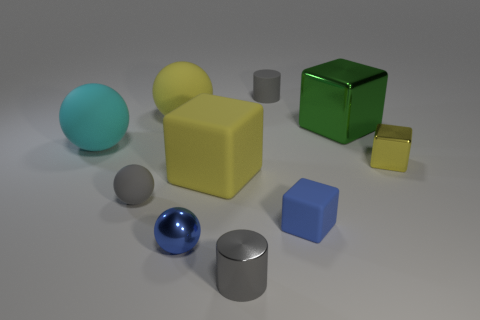Are the blue block and the small gray thing that is in front of the blue metal object made of the same material?
Offer a very short reply. No. There is a shiny thing that is on the right side of the tiny blue metal object and on the left side of the green metallic block; what is its color?
Make the answer very short. Gray. What number of spheres are large yellow matte things or small gray rubber objects?
Provide a short and direct response. 2. Do the big cyan rubber thing and the small metallic object behind the large matte cube have the same shape?
Offer a very short reply. No. There is a object that is both in front of the gray sphere and left of the gray shiny thing; what size is it?
Make the answer very short. Small. There is a cyan rubber thing; what shape is it?
Your response must be concise. Sphere. There is a large matte object that is behind the big shiny block; are there any large cyan matte things that are to the right of it?
Your answer should be compact. No. There is a tiny object that is behind the large cyan object; what number of yellow rubber objects are in front of it?
Your response must be concise. 2. There is another sphere that is the same size as the yellow rubber sphere; what material is it?
Your answer should be compact. Rubber. There is a small metallic thing that is on the right side of the green thing; does it have the same shape as the green metallic thing?
Your response must be concise. Yes. 